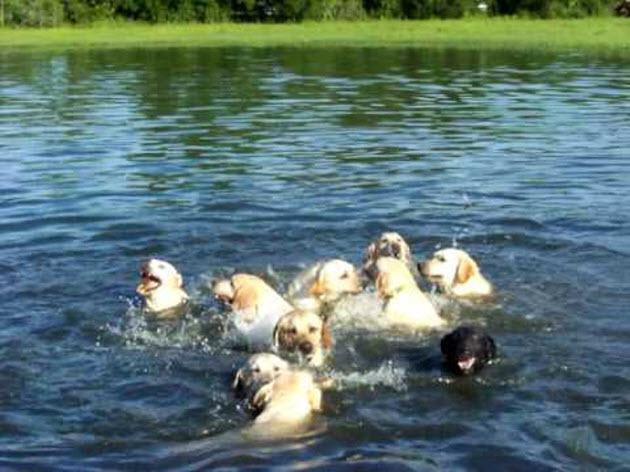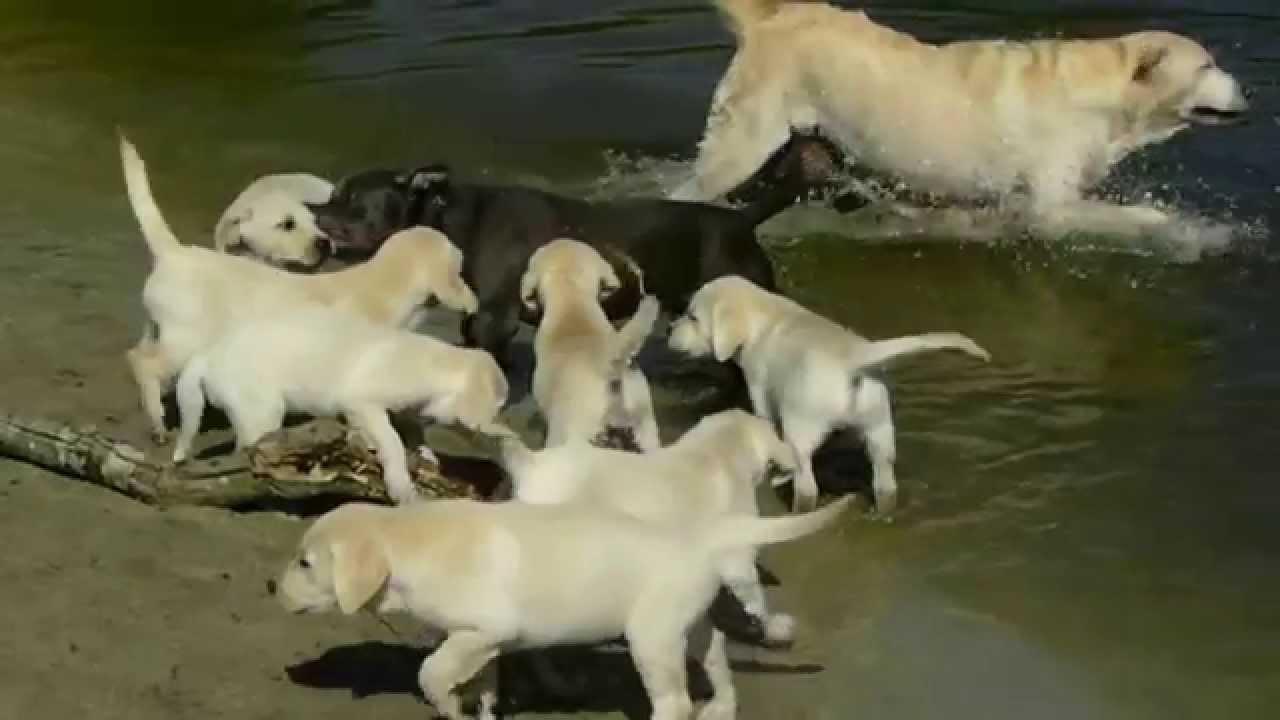The first image is the image on the left, the second image is the image on the right. Assess this claim about the two images: "The image on the right shows a group of dogs that are all sitting or lying down, and all but one of the dogs are showing their tongues.". Correct or not? Answer yes or no. No. The first image is the image on the left, the second image is the image on the right. For the images displayed, is the sentence "One of the images includes dogs on the grass." factually correct? Answer yes or no. No. 